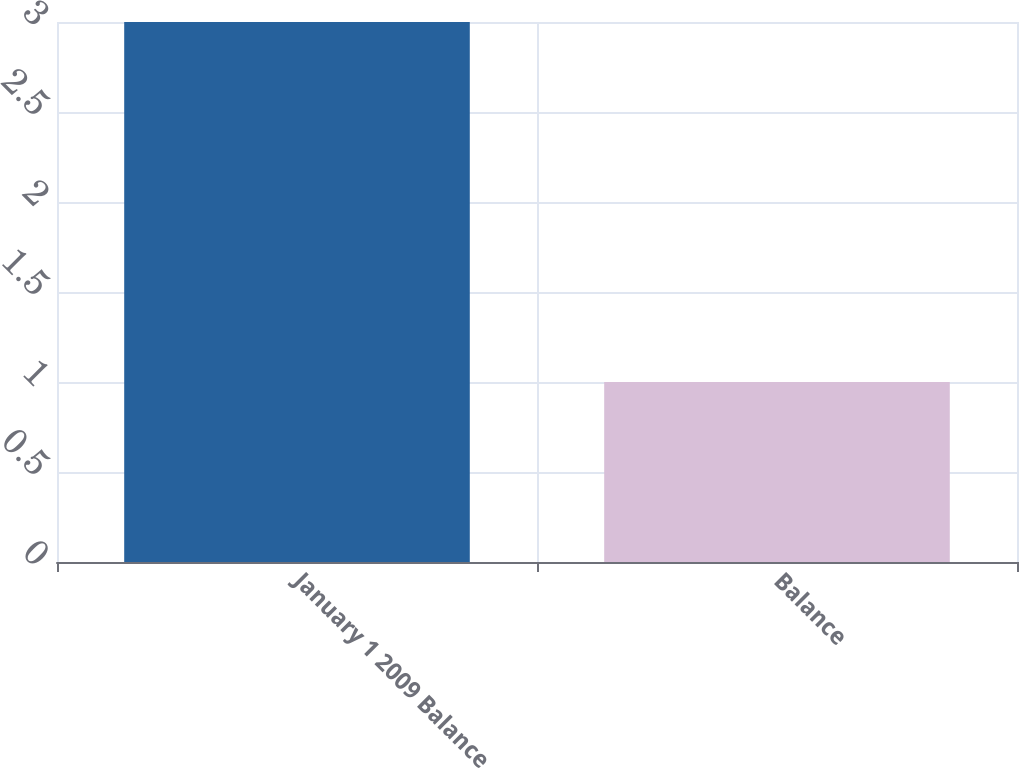Convert chart to OTSL. <chart><loc_0><loc_0><loc_500><loc_500><bar_chart><fcel>January 1 2009 Balance<fcel>Balance<nl><fcel>3<fcel>1<nl></chart> 